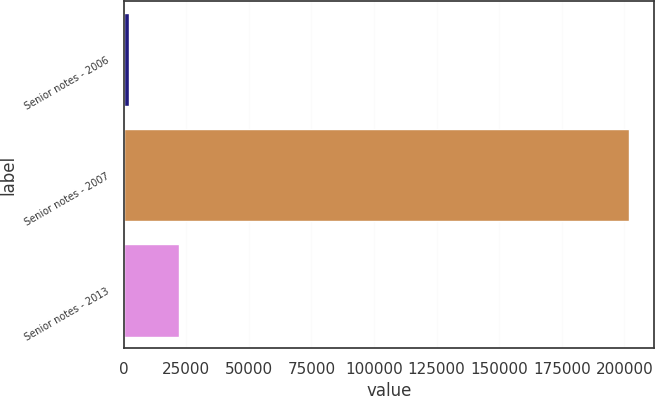Convert chart to OTSL. <chart><loc_0><loc_0><loc_500><loc_500><bar_chart><fcel>Senior notes - 2006<fcel>Senior notes - 2007<fcel>Senior notes - 2013<nl><fcel>2016<fcel>201727<fcel>21987.1<nl></chart> 